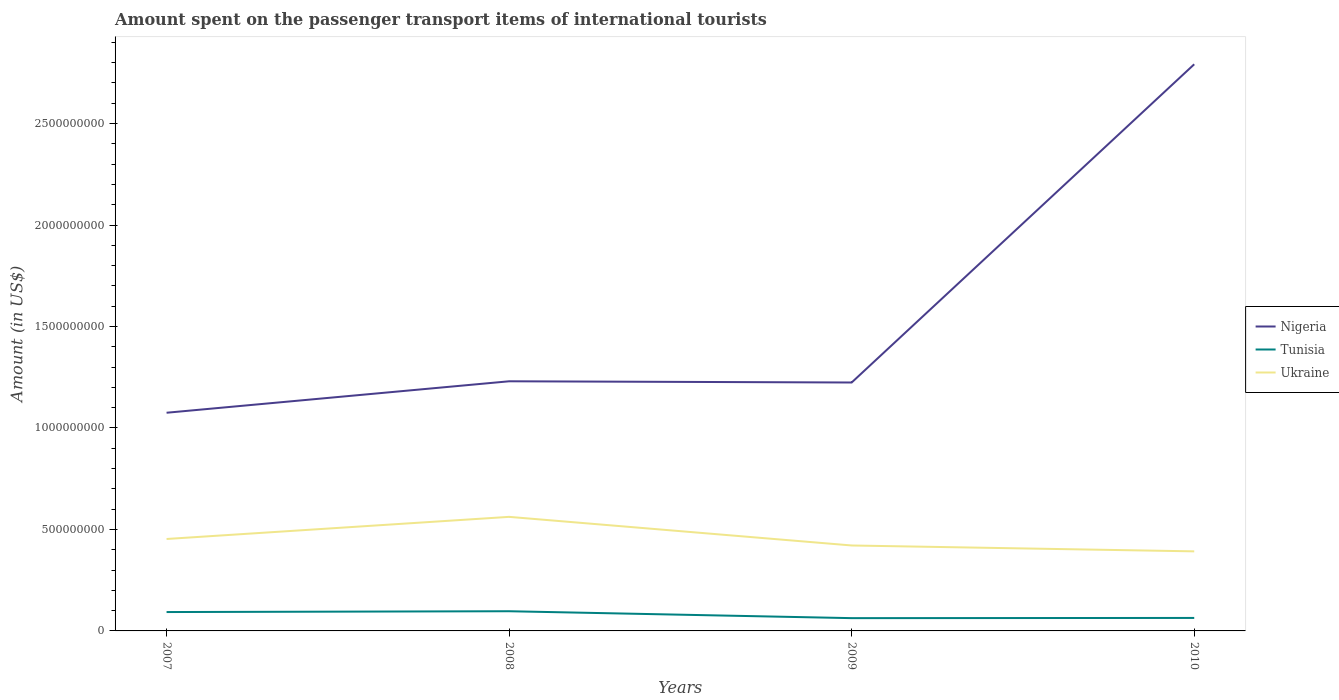How many different coloured lines are there?
Keep it short and to the point. 3. Does the line corresponding to Ukraine intersect with the line corresponding to Tunisia?
Keep it short and to the point. No. Is the number of lines equal to the number of legend labels?
Provide a short and direct response. Yes. Across all years, what is the maximum amount spent on the passenger transport items of international tourists in Nigeria?
Offer a very short reply. 1.08e+09. In which year was the amount spent on the passenger transport items of international tourists in Tunisia maximum?
Ensure brevity in your answer.  2009. What is the total amount spent on the passenger transport items of international tourists in Nigeria in the graph?
Make the answer very short. -1.72e+09. What is the difference between the highest and the second highest amount spent on the passenger transport items of international tourists in Nigeria?
Make the answer very short. 1.72e+09. How many lines are there?
Give a very brief answer. 3. How many years are there in the graph?
Ensure brevity in your answer.  4. What is the difference between two consecutive major ticks on the Y-axis?
Make the answer very short. 5.00e+08. Does the graph contain any zero values?
Give a very brief answer. No. Where does the legend appear in the graph?
Your response must be concise. Center right. How many legend labels are there?
Make the answer very short. 3. How are the legend labels stacked?
Provide a short and direct response. Vertical. What is the title of the graph?
Your response must be concise. Amount spent on the passenger transport items of international tourists. Does "Greece" appear as one of the legend labels in the graph?
Offer a very short reply. No. What is the label or title of the X-axis?
Your response must be concise. Years. What is the label or title of the Y-axis?
Your answer should be compact. Amount (in US$). What is the Amount (in US$) of Nigeria in 2007?
Keep it short and to the point. 1.08e+09. What is the Amount (in US$) in Tunisia in 2007?
Offer a very short reply. 9.30e+07. What is the Amount (in US$) in Ukraine in 2007?
Keep it short and to the point. 4.53e+08. What is the Amount (in US$) of Nigeria in 2008?
Your answer should be compact. 1.23e+09. What is the Amount (in US$) of Tunisia in 2008?
Provide a succinct answer. 9.70e+07. What is the Amount (in US$) in Ukraine in 2008?
Keep it short and to the point. 5.62e+08. What is the Amount (in US$) of Nigeria in 2009?
Your answer should be very brief. 1.22e+09. What is the Amount (in US$) in Tunisia in 2009?
Keep it short and to the point. 6.30e+07. What is the Amount (in US$) of Ukraine in 2009?
Ensure brevity in your answer.  4.21e+08. What is the Amount (in US$) of Nigeria in 2010?
Your response must be concise. 2.79e+09. What is the Amount (in US$) of Tunisia in 2010?
Offer a very short reply. 6.40e+07. What is the Amount (in US$) in Ukraine in 2010?
Offer a very short reply. 3.92e+08. Across all years, what is the maximum Amount (in US$) of Nigeria?
Give a very brief answer. 2.79e+09. Across all years, what is the maximum Amount (in US$) in Tunisia?
Your response must be concise. 9.70e+07. Across all years, what is the maximum Amount (in US$) of Ukraine?
Offer a very short reply. 5.62e+08. Across all years, what is the minimum Amount (in US$) in Nigeria?
Provide a succinct answer. 1.08e+09. Across all years, what is the minimum Amount (in US$) in Tunisia?
Give a very brief answer. 6.30e+07. Across all years, what is the minimum Amount (in US$) in Ukraine?
Provide a short and direct response. 3.92e+08. What is the total Amount (in US$) of Nigeria in the graph?
Make the answer very short. 6.32e+09. What is the total Amount (in US$) of Tunisia in the graph?
Your answer should be very brief. 3.17e+08. What is the total Amount (in US$) of Ukraine in the graph?
Offer a very short reply. 1.83e+09. What is the difference between the Amount (in US$) of Nigeria in 2007 and that in 2008?
Ensure brevity in your answer.  -1.55e+08. What is the difference between the Amount (in US$) of Tunisia in 2007 and that in 2008?
Offer a terse response. -4.00e+06. What is the difference between the Amount (in US$) in Ukraine in 2007 and that in 2008?
Provide a succinct answer. -1.09e+08. What is the difference between the Amount (in US$) in Nigeria in 2007 and that in 2009?
Keep it short and to the point. -1.49e+08. What is the difference between the Amount (in US$) in Tunisia in 2007 and that in 2009?
Your answer should be very brief. 3.00e+07. What is the difference between the Amount (in US$) in Ukraine in 2007 and that in 2009?
Make the answer very short. 3.20e+07. What is the difference between the Amount (in US$) of Nigeria in 2007 and that in 2010?
Provide a short and direct response. -1.72e+09. What is the difference between the Amount (in US$) in Tunisia in 2007 and that in 2010?
Give a very brief answer. 2.90e+07. What is the difference between the Amount (in US$) in Ukraine in 2007 and that in 2010?
Your response must be concise. 6.10e+07. What is the difference between the Amount (in US$) in Nigeria in 2008 and that in 2009?
Your answer should be very brief. 6.00e+06. What is the difference between the Amount (in US$) of Tunisia in 2008 and that in 2009?
Your answer should be compact. 3.40e+07. What is the difference between the Amount (in US$) of Ukraine in 2008 and that in 2009?
Your answer should be very brief. 1.41e+08. What is the difference between the Amount (in US$) in Nigeria in 2008 and that in 2010?
Your response must be concise. -1.56e+09. What is the difference between the Amount (in US$) of Tunisia in 2008 and that in 2010?
Ensure brevity in your answer.  3.30e+07. What is the difference between the Amount (in US$) in Ukraine in 2008 and that in 2010?
Make the answer very short. 1.70e+08. What is the difference between the Amount (in US$) of Nigeria in 2009 and that in 2010?
Provide a succinct answer. -1.57e+09. What is the difference between the Amount (in US$) in Ukraine in 2009 and that in 2010?
Your answer should be very brief. 2.90e+07. What is the difference between the Amount (in US$) of Nigeria in 2007 and the Amount (in US$) of Tunisia in 2008?
Provide a succinct answer. 9.78e+08. What is the difference between the Amount (in US$) in Nigeria in 2007 and the Amount (in US$) in Ukraine in 2008?
Provide a short and direct response. 5.13e+08. What is the difference between the Amount (in US$) of Tunisia in 2007 and the Amount (in US$) of Ukraine in 2008?
Provide a succinct answer. -4.69e+08. What is the difference between the Amount (in US$) in Nigeria in 2007 and the Amount (in US$) in Tunisia in 2009?
Ensure brevity in your answer.  1.01e+09. What is the difference between the Amount (in US$) of Nigeria in 2007 and the Amount (in US$) of Ukraine in 2009?
Your answer should be compact. 6.54e+08. What is the difference between the Amount (in US$) in Tunisia in 2007 and the Amount (in US$) in Ukraine in 2009?
Provide a short and direct response. -3.28e+08. What is the difference between the Amount (in US$) of Nigeria in 2007 and the Amount (in US$) of Tunisia in 2010?
Provide a short and direct response. 1.01e+09. What is the difference between the Amount (in US$) in Nigeria in 2007 and the Amount (in US$) in Ukraine in 2010?
Your answer should be very brief. 6.83e+08. What is the difference between the Amount (in US$) of Tunisia in 2007 and the Amount (in US$) of Ukraine in 2010?
Give a very brief answer. -2.99e+08. What is the difference between the Amount (in US$) of Nigeria in 2008 and the Amount (in US$) of Tunisia in 2009?
Ensure brevity in your answer.  1.17e+09. What is the difference between the Amount (in US$) of Nigeria in 2008 and the Amount (in US$) of Ukraine in 2009?
Make the answer very short. 8.09e+08. What is the difference between the Amount (in US$) of Tunisia in 2008 and the Amount (in US$) of Ukraine in 2009?
Provide a short and direct response. -3.24e+08. What is the difference between the Amount (in US$) of Nigeria in 2008 and the Amount (in US$) of Tunisia in 2010?
Ensure brevity in your answer.  1.17e+09. What is the difference between the Amount (in US$) of Nigeria in 2008 and the Amount (in US$) of Ukraine in 2010?
Offer a very short reply. 8.38e+08. What is the difference between the Amount (in US$) of Tunisia in 2008 and the Amount (in US$) of Ukraine in 2010?
Keep it short and to the point. -2.95e+08. What is the difference between the Amount (in US$) of Nigeria in 2009 and the Amount (in US$) of Tunisia in 2010?
Make the answer very short. 1.16e+09. What is the difference between the Amount (in US$) of Nigeria in 2009 and the Amount (in US$) of Ukraine in 2010?
Offer a very short reply. 8.32e+08. What is the difference between the Amount (in US$) of Tunisia in 2009 and the Amount (in US$) of Ukraine in 2010?
Offer a very short reply. -3.29e+08. What is the average Amount (in US$) in Nigeria per year?
Make the answer very short. 1.58e+09. What is the average Amount (in US$) of Tunisia per year?
Ensure brevity in your answer.  7.92e+07. What is the average Amount (in US$) of Ukraine per year?
Keep it short and to the point. 4.57e+08. In the year 2007, what is the difference between the Amount (in US$) of Nigeria and Amount (in US$) of Tunisia?
Your answer should be very brief. 9.82e+08. In the year 2007, what is the difference between the Amount (in US$) of Nigeria and Amount (in US$) of Ukraine?
Ensure brevity in your answer.  6.22e+08. In the year 2007, what is the difference between the Amount (in US$) of Tunisia and Amount (in US$) of Ukraine?
Your answer should be compact. -3.60e+08. In the year 2008, what is the difference between the Amount (in US$) in Nigeria and Amount (in US$) in Tunisia?
Your response must be concise. 1.13e+09. In the year 2008, what is the difference between the Amount (in US$) of Nigeria and Amount (in US$) of Ukraine?
Your answer should be very brief. 6.68e+08. In the year 2008, what is the difference between the Amount (in US$) in Tunisia and Amount (in US$) in Ukraine?
Give a very brief answer. -4.65e+08. In the year 2009, what is the difference between the Amount (in US$) of Nigeria and Amount (in US$) of Tunisia?
Give a very brief answer. 1.16e+09. In the year 2009, what is the difference between the Amount (in US$) of Nigeria and Amount (in US$) of Ukraine?
Keep it short and to the point. 8.03e+08. In the year 2009, what is the difference between the Amount (in US$) of Tunisia and Amount (in US$) of Ukraine?
Your response must be concise. -3.58e+08. In the year 2010, what is the difference between the Amount (in US$) of Nigeria and Amount (in US$) of Tunisia?
Provide a succinct answer. 2.73e+09. In the year 2010, what is the difference between the Amount (in US$) in Nigeria and Amount (in US$) in Ukraine?
Your response must be concise. 2.40e+09. In the year 2010, what is the difference between the Amount (in US$) of Tunisia and Amount (in US$) of Ukraine?
Offer a very short reply. -3.28e+08. What is the ratio of the Amount (in US$) in Nigeria in 2007 to that in 2008?
Ensure brevity in your answer.  0.87. What is the ratio of the Amount (in US$) of Tunisia in 2007 to that in 2008?
Provide a short and direct response. 0.96. What is the ratio of the Amount (in US$) of Ukraine in 2007 to that in 2008?
Your response must be concise. 0.81. What is the ratio of the Amount (in US$) in Nigeria in 2007 to that in 2009?
Ensure brevity in your answer.  0.88. What is the ratio of the Amount (in US$) in Tunisia in 2007 to that in 2009?
Offer a very short reply. 1.48. What is the ratio of the Amount (in US$) of Ukraine in 2007 to that in 2009?
Your response must be concise. 1.08. What is the ratio of the Amount (in US$) of Nigeria in 2007 to that in 2010?
Offer a terse response. 0.39. What is the ratio of the Amount (in US$) in Tunisia in 2007 to that in 2010?
Ensure brevity in your answer.  1.45. What is the ratio of the Amount (in US$) in Ukraine in 2007 to that in 2010?
Offer a terse response. 1.16. What is the ratio of the Amount (in US$) in Nigeria in 2008 to that in 2009?
Your response must be concise. 1. What is the ratio of the Amount (in US$) in Tunisia in 2008 to that in 2009?
Provide a succinct answer. 1.54. What is the ratio of the Amount (in US$) of Ukraine in 2008 to that in 2009?
Offer a terse response. 1.33. What is the ratio of the Amount (in US$) of Nigeria in 2008 to that in 2010?
Give a very brief answer. 0.44. What is the ratio of the Amount (in US$) of Tunisia in 2008 to that in 2010?
Your response must be concise. 1.52. What is the ratio of the Amount (in US$) of Ukraine in 2008 to that in 2010?
Ensure brevity in your answer.  1.43. What is the ratio of the Amount (in US$) of Nigeria in 2009 to that in 2010?
Offer a terse response. 0.44. What is the ratio of the Amount (in US$) of Tunisia in 2009 to that in 2010?
Your answer should be compact. 0.98. What is the ratio of the Amount (in US$) of Ukraine in 2009 to that in 2010?
Provide a succinct answer. 1.07. What is the difference between the highest and the second highest Amount (in US$) in Nigeria?
Ensure brevity in your answer.  1.56e+09. What is the difference between the highest and the second highest Amount (in US$) in Ukraine?
Your answer should be compact. 1.09e+08. What is the difference between the highest and the lowest Amount (in US$) in Nigeria?
Your response must be concise. 1.72e+09. What is the difference between the highest and the lowest Amount (in US$) in Tunisia?
Make the answer very short. 3.40e+07. What is the difference between the highest and the lowest Amount (in US$) of Ukraine?
Offer a very short reply. 1.70e+08. 